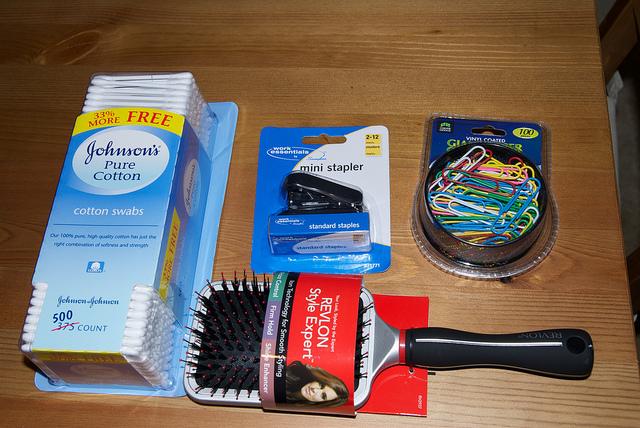Where can you buy all these articles?
Keep it brief. Drugstore. How many Q tips are there in the box?
Keep it brief. 500. Can the woman in the picture use the stapler?
Give a very brief answer. No. 